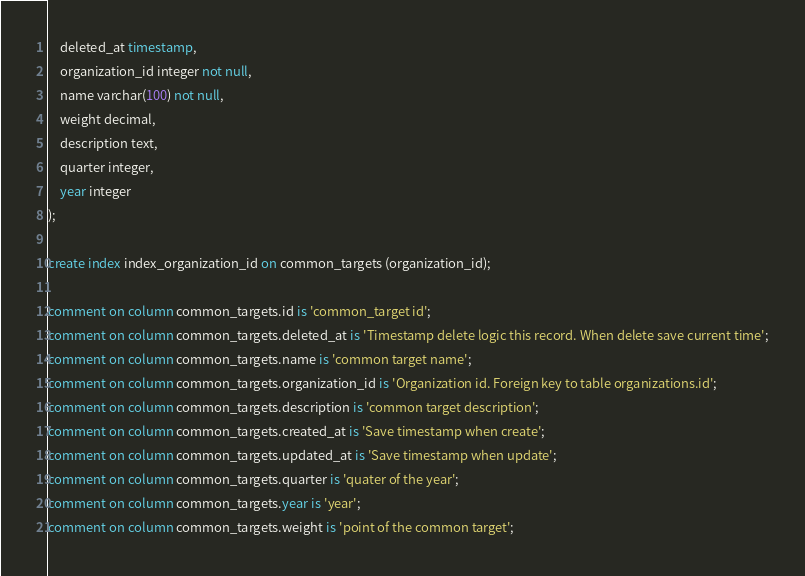Convert code to text. <code><loc_0><loc_0><loc_500><loc_500><_SQL_>    deleted_at timestamp,
    organization_id integer not null,
    name varchar(100) not null,
    weight decimal,
    description text,
    quarter integer,
    year integer
);

create index index_organization_id on common_targets (organization_id);

comment on column common_targets.id is 'common_target id';
comment on column common_targets.deleted_at is 'Timestamp delete logic this record. When delete save current time';
comment on column common_targets.name is 'common target name';
comment on column common_targets.organization_id is 'Organization id. Foreign key to table organizations.id';
comment on column common_targets.description is 'common target description';
comment on column common_targets.created_at is 'Save timestamp when create';
comment on column common_targets.updated_at is 'Save timestamp when update';
comment on column common_targets.quarter is 'quater of the year';
comment on column common_targets.year is 'year';
comment on column common_targets.weight is 'point of the common target';
</code> 